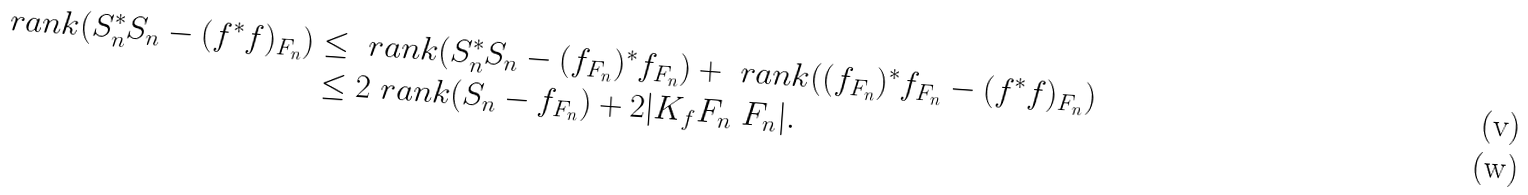<formula> <loc_0><loc_0><loc_500><loc_500>\ r a n k ( S ^ { * } _ { n } S _ { n } - ( f ^ { * } f ) _ { F _ { n } } ) & \leq \ r a n k ( S _ { n } ^ { * } S _ { n } - ( f _ { F _ { n } } ) ^ { * } f _ { F _ { n } } ) + \ r a n k ( ( f _ { F _ { n } } ) ^ { * } f _ { F _ { n } } - ( f ^ { * } f ) _ { F _ { n } } ) \\ & \leq 2 \ r a n k ( S _ { n } - f _ { F _ { n } } ) + 2 | K _ { f } F _ { n } \ F _ { n } | .</formula> 